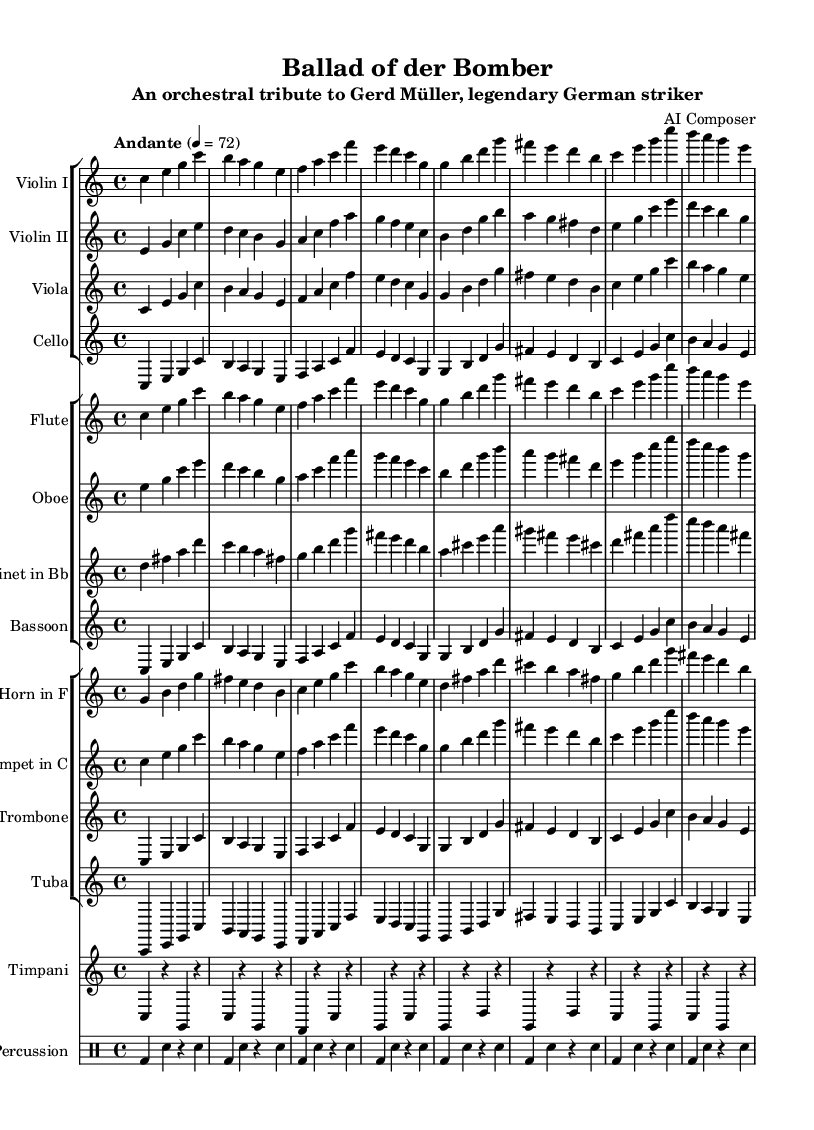What is the key signature of this music? The key signature in the music indicates C major, which has no sharps or flats. This can be visually confirmed at the beginning of the score.
Answer: C major What is the time signature of this music? The time signature is indicated as 4/4 at the beginning of the score, which shows that there are four beats per measure and the quarter note gets one beat.
Answer: 4/4 What is the tempo marking for this piece? The tempo marking is "Andante," which is stated near the beginning of the score, specifically indicating a moderate pace.
Answer: Andante Which instrument plays the main melody first? The first melodic lines in the score are found in the Violin I part, which starts right away and features distinct melodic phrases.
Answer: Violin I How many measures are there in the first section of the score? By counting the measures in the provided parts, there are a total of 8 measures in the first section of the score, as indicated in each instrumental part.
Answer: 8 What type of musical composition is this? This piece is categorized as a symphony, specifically created to celebrate German football legends, which is evident from the title and context provided in the header.
Answer: Symphony What is the main theme or subject of this orchestral piece? The main theme is a tribute to Gerd Müller, referred to as "der Bomber," which connects the music directly to this legendary football player and his achievements as indicated in the subtitle.
Answer: Gerd Müller 